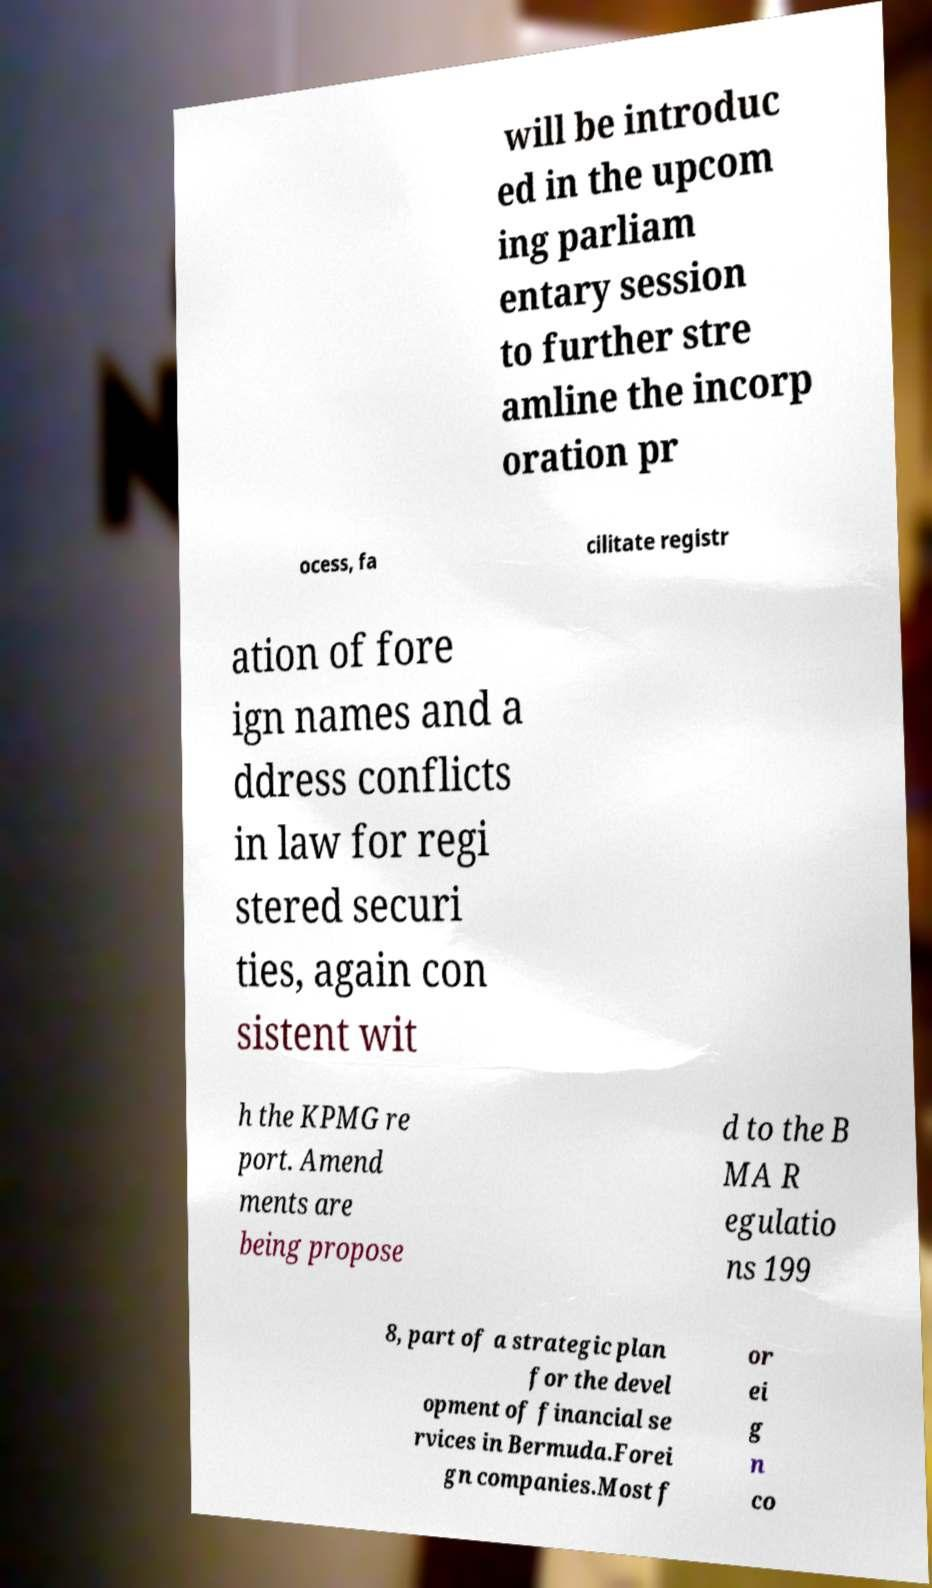Could you extract and type out the text from this image? will be introduc ed in the upcom ing parliam entary session to further stre amline the incorp oration pr ocess, fa cilitate registr ation of fore ign names and a ddress conflicts in law for regi stered securi ties, again con sistent wit h the KPMG re port. Amend ments are being propose d to the B MA R egulatio ns 199 8, part of a strategic plan for the devel opment of financial se rvices in Bermuda.Forei gn companies.Most f or ei g n co 